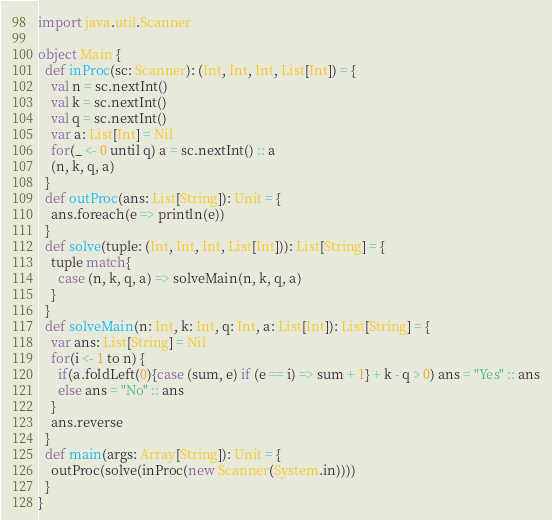Convert code to text. <code><loc_0><loc_0><loc_500><loc_500><_Scala_>import java.util.Scanner

object Main {
  def inProc(sc: Scanner): (Int, Int, Int, List[Int]) = {
    val n = sc.nextInt()
    val k = sc.nextInt()
    val q = sc.nextInt()
    var a: List[Int] = Nil
    for(_ <- 0 until q) a = sc.nextInt() :: a
    (n, k, q, a)
  }
  def outProc(ans: List[String]): Unit = {
    ans.foreach(e => println(e))
  }
  def solve(tuple: (Int, Int, Int, List[Int])): List[String] = {
    tuple match{
      case (n, k, q, a) => solveMain(n, k, q, a)
    }
  }
  def solveMain(n: Int, k: Int, q: Int, a: List[Int]): List[String] = {
    var ans: List[String] = Nil
    for(i <- 1 to n) {
      if(a.foldLeft(0){case (sum, e) if (e == i) => sum + 1} + k - q > 0) ans = "Yes" :: ans
      else ans = "No" :: ans
    }
    ans.reverse
  }
  def main(args: Array[String]): Unit = {
    outProc(solve(inProc(new Scanner(System.in))))
  }
}
</code> 